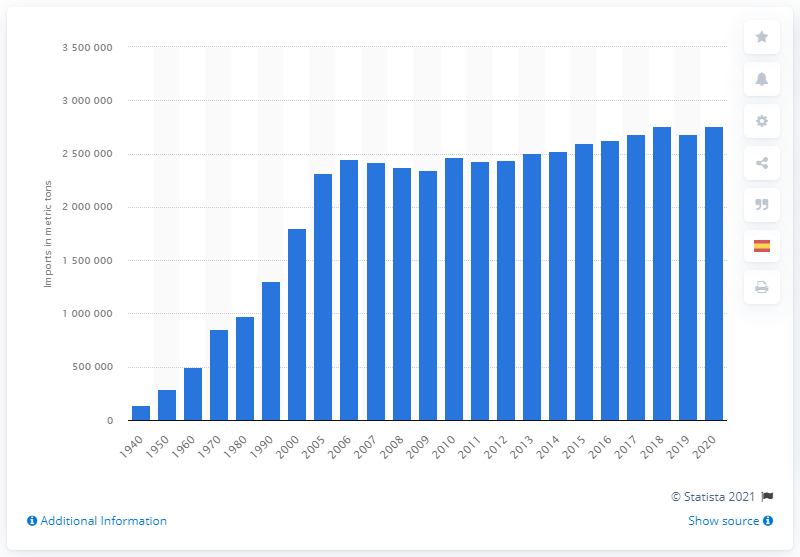List a handful of essential elements in this visual. The United States first imported edible fishery products in 1940. In 2019, the United States imported a total of 268,590,900 metric tons of edible fishery products. 